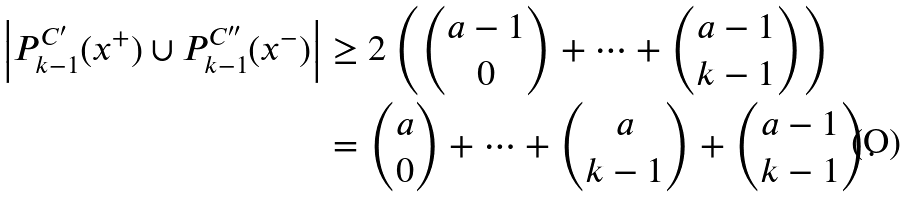Convert formula to latex. <formula><loc_0><loc_0><loc_500><loc_500>\left | P _ { k - 1 } ^ { C ^ { \prime } } ( x ^ { + } ) \cup P _ { k - 1 } ^ { C ^ { \prime \prime } } ( x ^ { - } ) \right | & \geq 2 \left ( \binom { a - 1 } { 0 } + \dots + \binom { a - 1 } { k - 1 } \right ) \\ & = \binom { a } { 0 } + \dots + \binom { a } { k - 1 } + \binom { a - 1 } { k - 1 } .</formula> 